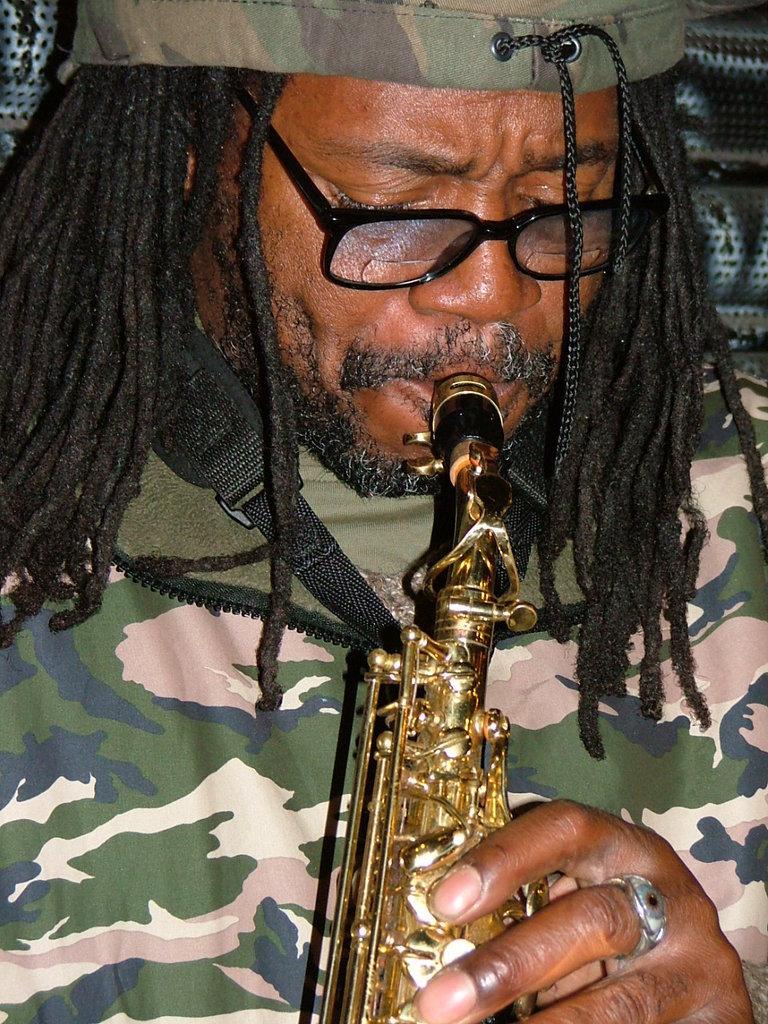Can you describe this image briefly? In this image there is one person holding an instrument as we can see in middle of this image. 